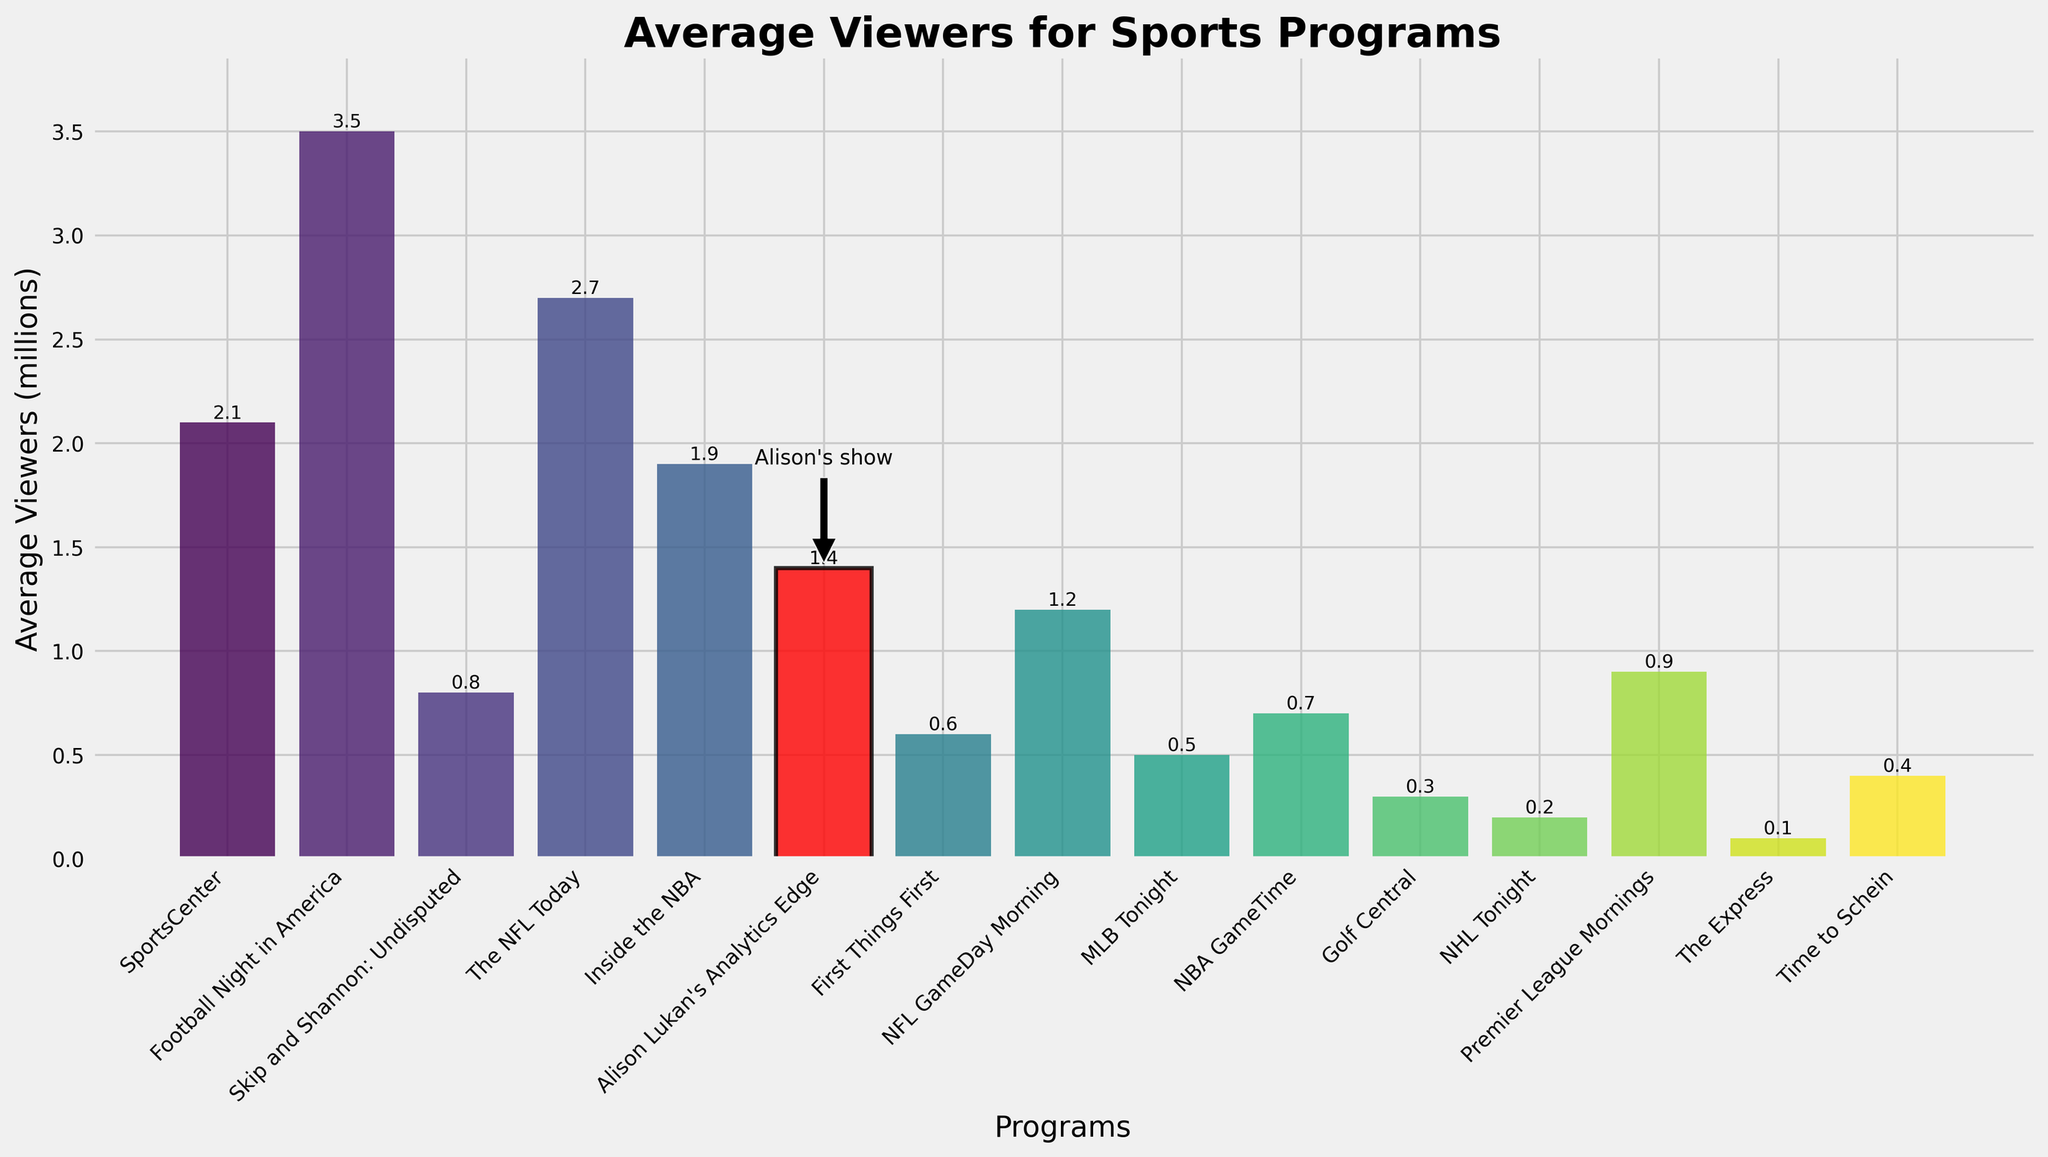Which program has the highest average viewers? To answer this, look for the tallest bar in the chart. The tallest bar represents the program with the highest average viewers.
Answer: Football Night in America Where does Alison Lukan's show rank in terms of average viewers? Examine the height of the bar corresponding to "Alison Lukan's Analytics Edge" and compare it to the heights of other bars to determine its relative ranking.
Answer: 7th How many more viewers does Football Night in America have compared to Alison Lukan's Analytics Edge? Find the heights of the bars representing each program and subtract the average viewers of Alison's show from the average viewers of Football Night in America (3.5 - 1.4).
Answer: 2.1 million Which program has the fewest average viewers and how many does it have? Look for the shortest bar in the chart and read off its height to find the program with the fewest average viewers.
Answer: The Express, 0.1 million What is the average viewership of programs on CBS Sports and CBS Sports Network combined? Find the bars for "The NFL Today" and "Time to Schein", sum their heights (2.7 + 0.4), then divide by 2 for the average.
Answer: 1.55 million Is there any program on Fox Sports that has a higher viewership than Alison Lukan's show? Compare the height of the bar for "Skip and Shannon: Undisputed" on Fox Sports (0.8) with that of "Alison Lukan's Analytics Edge" (1.4).
Answer: No How does the viewership of Inside the NBA compare to SportsCenter? Examine the heights of the bars for "Inside the NBA" (1.9) and "SportsCenter" (2.1) to compare their viewerships.
Answer: SportsCenter has more viewers What is the sum of the viewership for the three programs with the highest average viewers? Find the values for "Football Night in America" (3.5), "The NFL Today" (2.7), and "SportsCenter" (2.1) and sum them up (3.5 + 2.7 + 2.1).
Answer: 8.3 million Which program has a viewership closest to the average viewership of Alison Lukan's show? Compare the viewership of Alison Lukan's show (1.4) to other programs, specifically looking for the bar height closest to 1.4.
Answer: NFL GameDay Morning (1.2 million) What visual cues are used to highlight Alison Lukan's show in the chart? Look for distinct visual attributes such as color, border, and annotations used for the bar representing Alison's show.
Answer: Red color, black border, and an annotation 